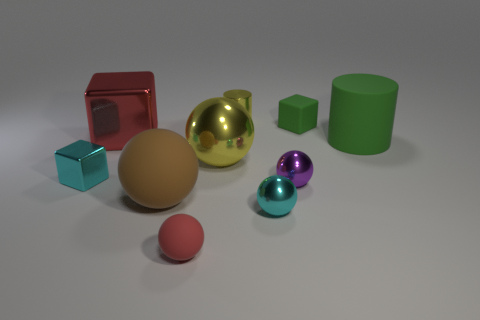Subtract all purple spheres. How many spheres are left? 4 Subtract all tiny purple spheres. How many spheres are left? 4 Subtract all gray spheres. Subtract all green cubes. How many spheres are left? 5 Subtract all cylinders. How many objects are left? 8 Subtract all tiny brown rubber things. Subtract all tiny red spheres. How many objects are left? 9 Add 7 cyan cubes. How many cyan cubes are left? 8 Add 9 tiny green objects. How many tiny green objects exist? 10 Subtract 1 red blocks. How many objects are left? 9 